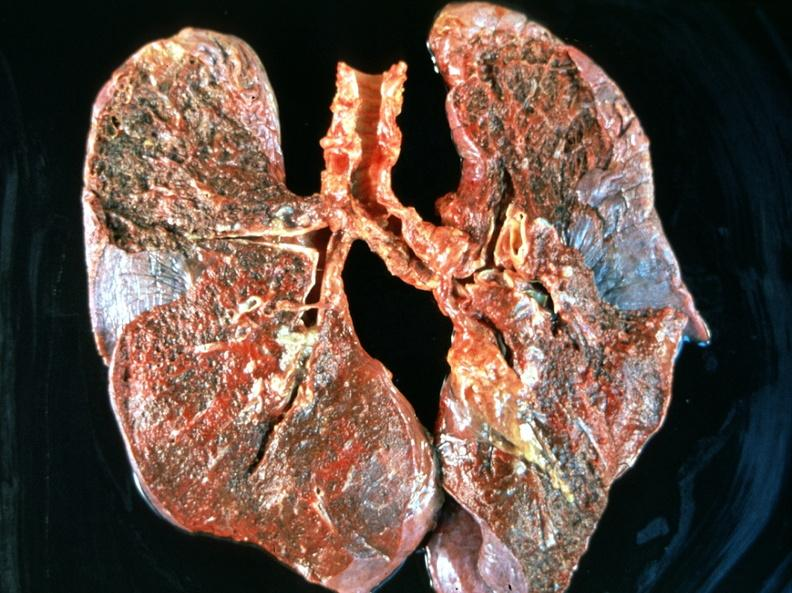does pituitary show breast cancer metastasis to lung?
Answer the question using a single word or phrase. No 